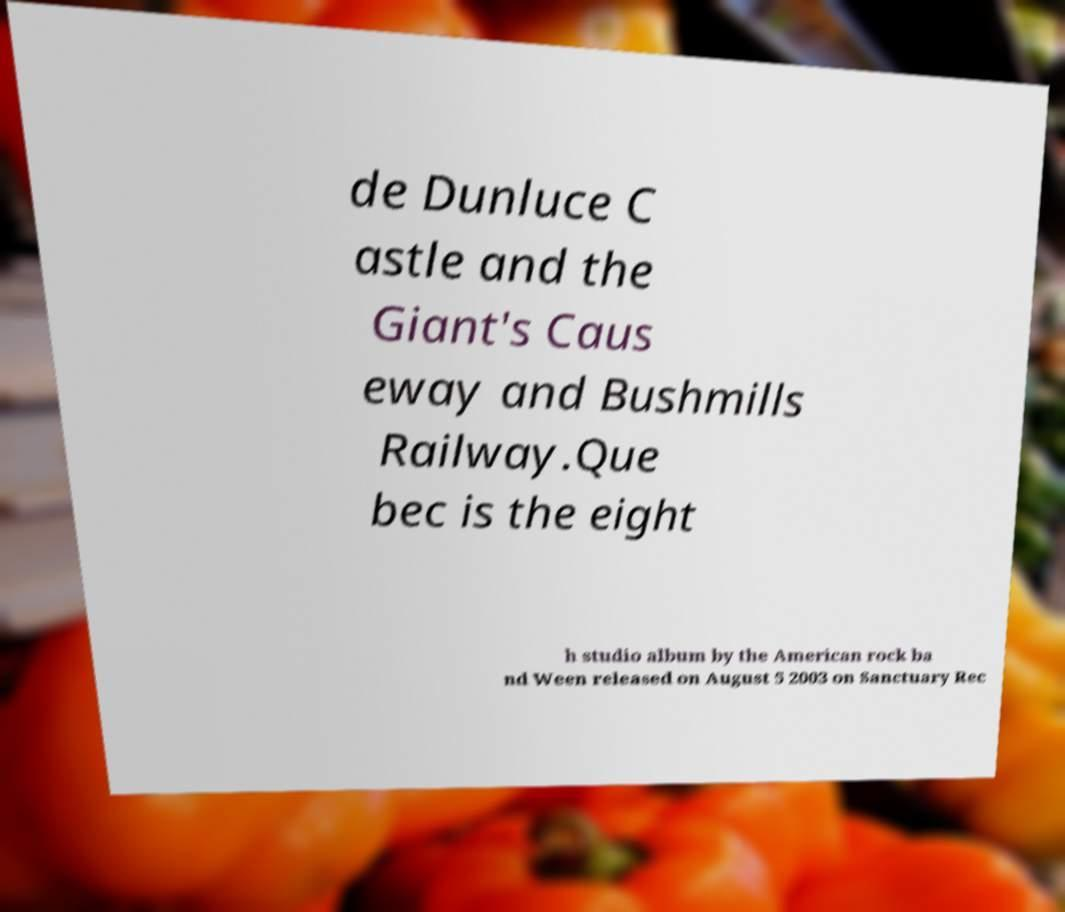There's text embedded in this image that I need extracted. Can you transcribe it verbatim? de Dunluce C astle and the Giant's Caus eway and Bushmills Railway.Que bec is the eight h studio album by the American rock ba nd Ween released on August 5 2003 on Sanctuary Rec 